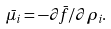<formula> <loc_0><loc_0><loc_500><loc_500>\bar { \mu } _ { i } = - \partial \bar { f } / \partial \rho _ { i } .</formula> 